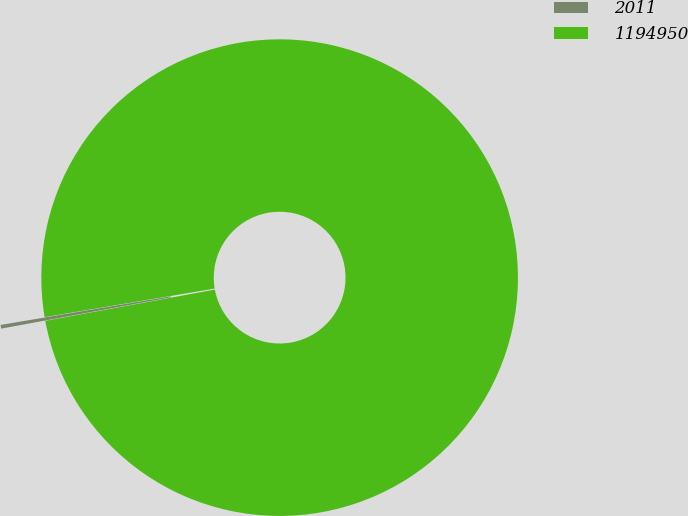Convert chart to OTSL. <chart><loc_0><loc_0><loc_500><loc_500><pie_chart><fcel>2011<fcel>1194950<nl><fcel>0.25%<fcel>99.75%<nl></chart> 